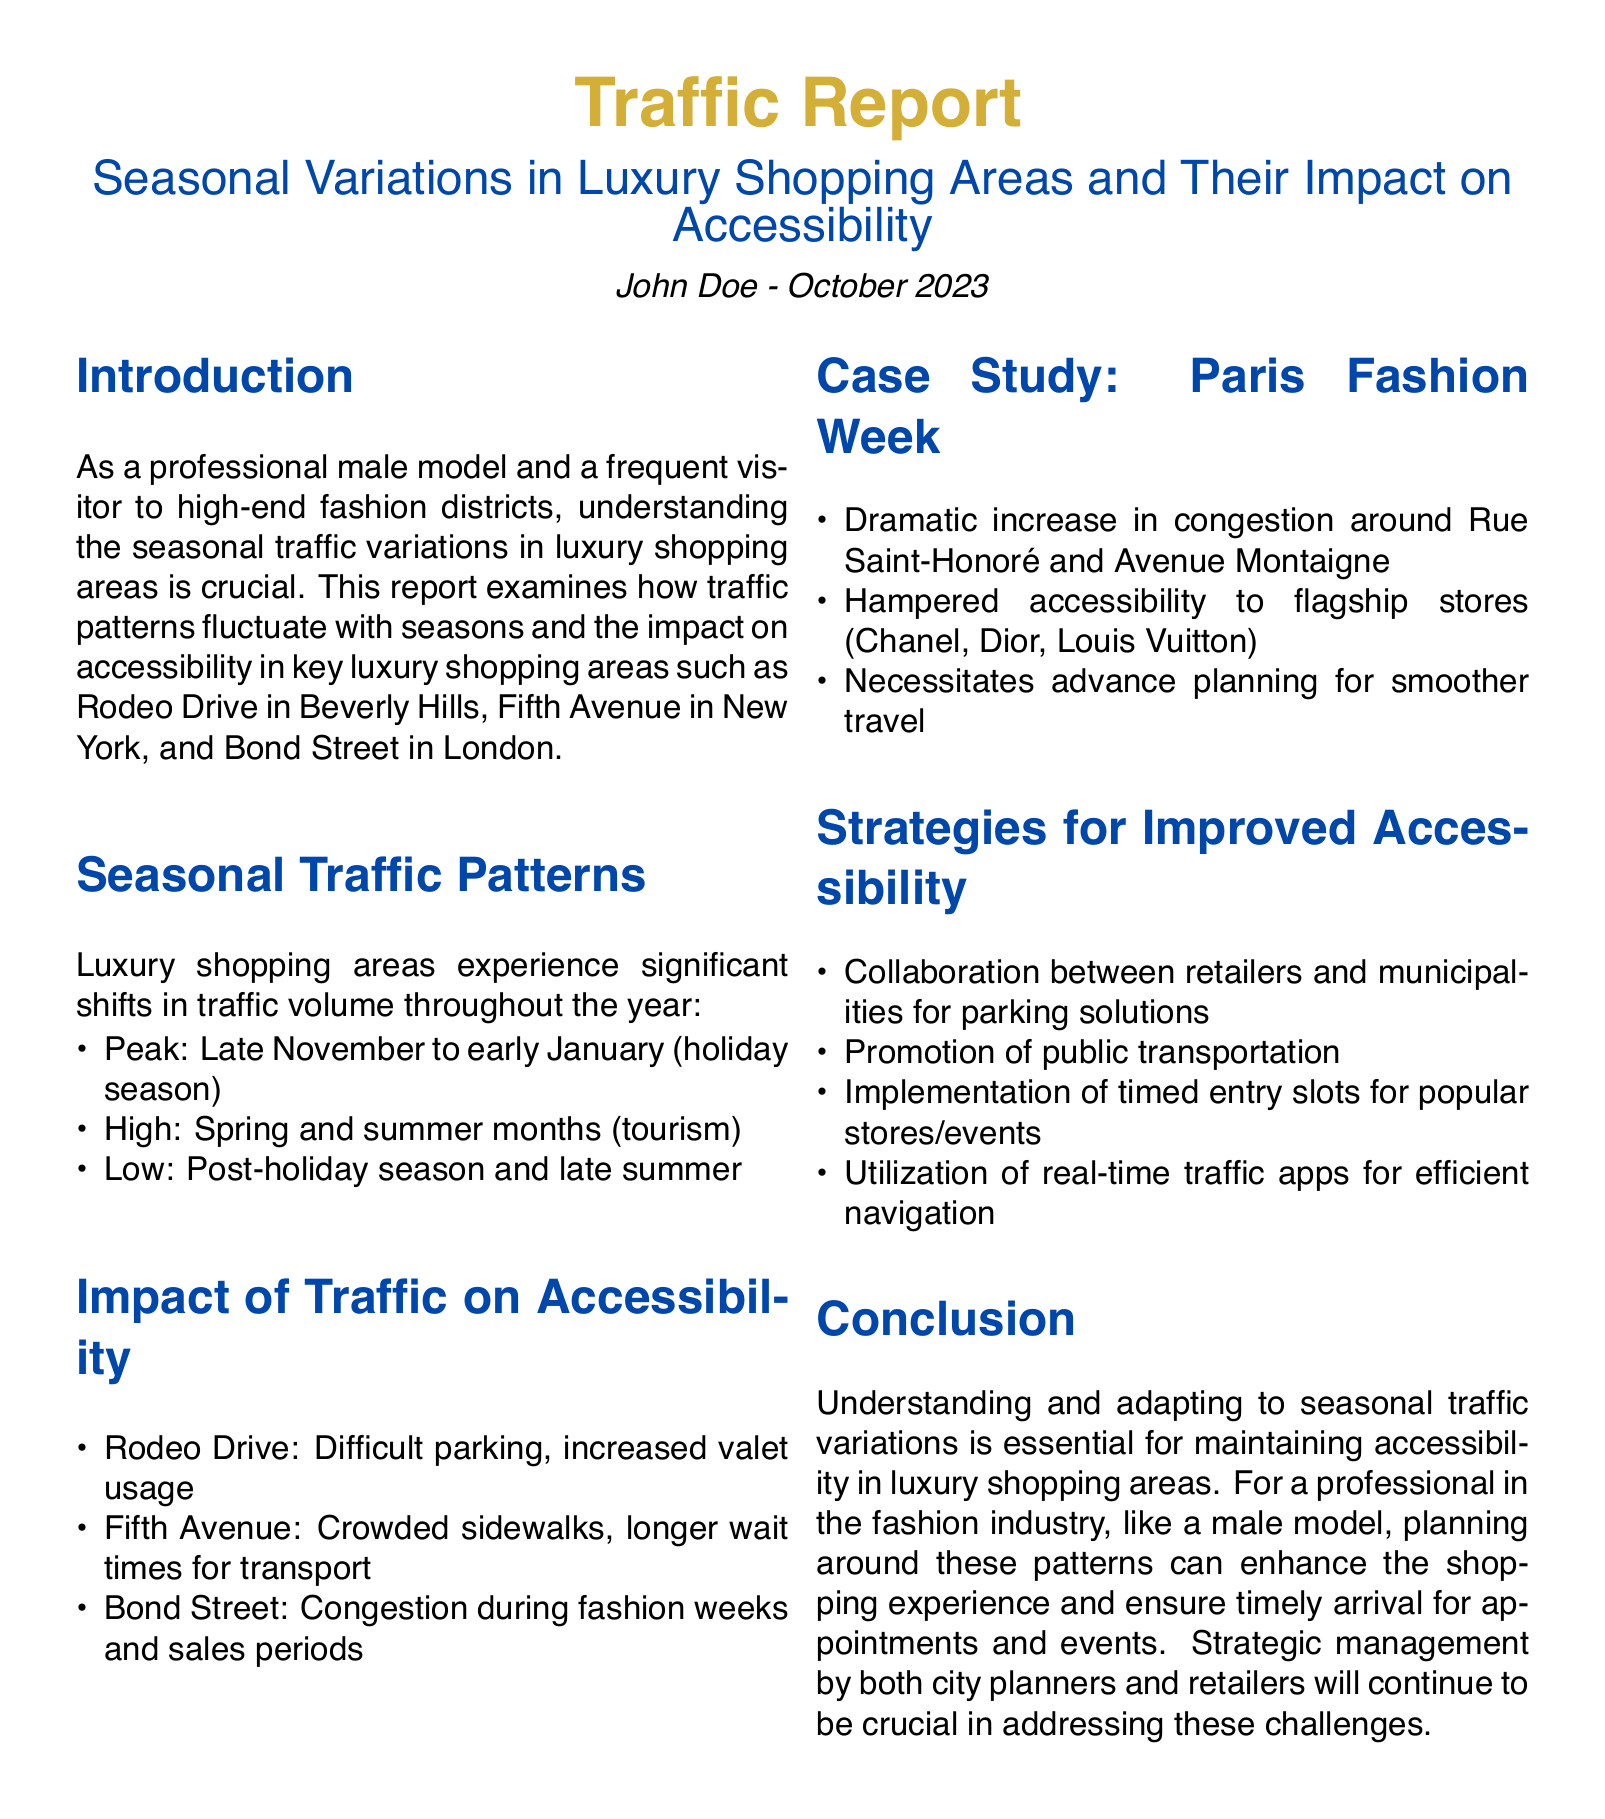What is the peak traffic season for luxury shopping areas? The report identifies late November to early January as the peak traffic season due to the holiday season.
Answer: Late November to early January What is a notable impact of traffic on Fifth Avenue? The report mentions that Fifth Avenue experiences crowded sidewalks and longer wait times for transport during high traffic periods.
Answer: Crowded sidewalks What area is referenced in the case study for Paris Fashion Week? The case study highlights Rue Saint-Honoré and Avenue Montaigne as areas with dramatic congestion during Paris Fashion Week.
Answer: Rue Saint-Honoré and Avenue Montaigne What is one strategy suggested for improved accessibility? The report proposes collaboration between retailers and municipalities for parking solutions as a strategy for improving accessibility.
Answer: Collaboration between retailers and municipalities During which months does high traffic occur? The report specifies that high traffic occurs during the spring and summer months, typically due to tourism.
Answer: Spring and summer What is a consequence of congestion around luxury shopping areas? The report states that congestion can hamper accessibility to flagship stores like Chanel and Dior during peak events.
Answer: Hampered accessibility Who authored the traffic report? The report attributes authorship to John Doe in October 2023.
Answer: John Doe What is one suggested method for navigation during high traffic times? The report suggests utilizing real-time traffic apps for efficient navigation in congested areas.
Answer: Real-time traffic apps 